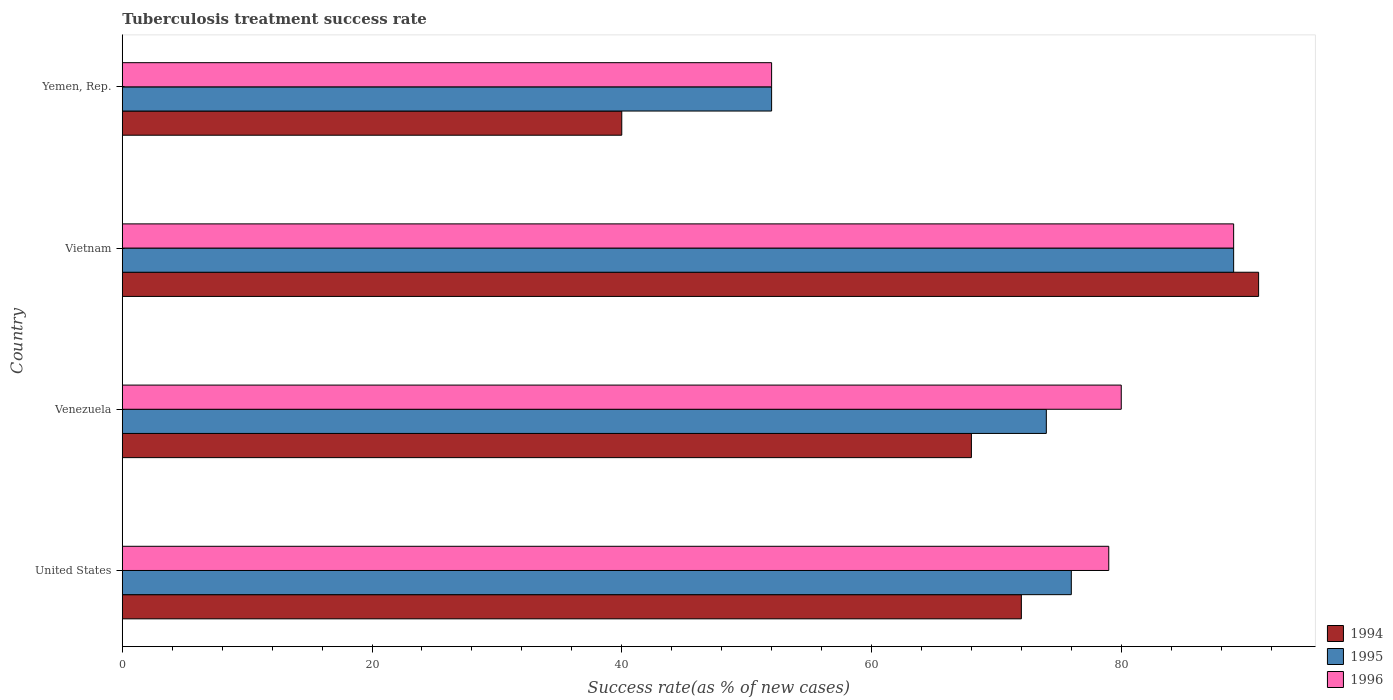How many different coloured bars are there?
Offer a terse response. 3. Are the number of bars on each tick of the Y-axis equal?
Your answer should be very brief. Yes. What is the tuberculosis treatment success rate in 1995 in Yemen, Rep.?
Give a very brief answer. 52. Across all countries, what is the maximum tuberculosis treatment success rate in 1995?
Offer a terse response. 89. Across all countries, what is the minimum tuberculosis treatment success rate in 1995?
Provide a short and direct response. 52. In which country was the tuberculosis treatment success rate in 1994 maximum?
Provide a succinct answer. Vietnam. In which country was the tuberculosis treatment success rate in 1995 minimum?
Your answer should be compact. Yemen, Rep. What is the total tuberculosis treatment success rate in 1995 in the graph?
Ensure brevity in your answer.  291. What is the difference between the tuberculosis treatment success rate in 1996 in United States and the tuberculosis treatment success rate in 1995 in Venezuela?
Provide a succinct answer. 5. What is the average tuberculosis treatment success rate in 1995 per country?
Provide a succinct answer. 72.75. In how many countries, is the tuberculosis treatment success rate in 1996 greater than 28 %?
Your answer should be compact. 4. What is the ratio of the tuberculosis treatment success rate in 1996 in Venezuela to that in Yemen, Rep.?
Keep it short and to the point. 1.54. Is the tuberculosis treatment success rate in 1994 in Venezuela less than that in Yemen, Rep.?
Give a very brief answer. No. What is the difference between the highest and the second highest tuberculosis treatment success rate in 1996?
Offer a terse response. 9. In how many countries, is the tuberculosis treatment success rate in 1996 greater than the average tuberculosis treatment success rate in 1996 taken over all countries?
Your response must be concise. 3. Is the sum of the tuberculosis treatment success rate in 1995 in Vietnam and Yemen, Rep. greater than the maximum tuberculosis treatment success rate in 1996 across all countries?
Your response must be concise. Yes. Is it the case that in every country, the sum of the tuberculosis treatment success rate in 1995 and tuberculosis treatment success rate in 1996 is greater than the tuberculosis treatment success rate in 1994?
Give a very brief answer. Yes. How many bars are there?
Your answer should be very brief. 12. How many countries are there in the graph?
Ensure brevity in your answer.  4. Where does the legend appear in the graph?
Offer a very short reply. Bottom right. What is the title of the graph?
Your answer should be very brief. Tuberculosis treatment success rate. Does "1984" appear as one of the legend labels in the graph?
Provide a succinct answer. No. What is the label or title of the X-axis?
Make the answer very short. Success rate(as % of new cases). What is the label or title of the Y-axis?
Offer a very short reply. Country. What is the Success rate(as % of new cases) in 1996 in United States?
Provide a succinct answer. 79. What is the Success rate(as % of new cases) of 1996 in Venezuela?
Keep it short and to the point. 80. What is the Success rate(as % of new cases) in 1994 in Vietnam?
Offer a terse response. 91. What is the Success rate(as % of new cases) of 1995 in Vietnam?
Offer a very short reply. 89. What is the Success rate(as % of new cases) of 1996 in Vietnam?
Your answer should be very brief. 89. What is the Success rate(as % of new cases) in 1995 in Yemen, Rep.?
Ensure brevity in your answer.  52. What is the Success rate(as % of new cases) of 1996 in Yemen, Rep.?
Your answer should be very brief. 52. Across all countries, what is the maximum Success rate(as % of new cases) of 1994?
Provide a succinct answer. 91. Across all countries, what is the maximum Success rate(as % of new cases) in 1995?
Offer a terse response. 89. Across all countries, what is the maximum Success rate(as % of new cases) of 1996?
Offer a very short reply. 89. Across all countries, what is the minimum Success rate(as % of new cases) of 1994?
Give a very brief answer. 40. Across all countries, what is the minimum Success rate(as % of new cases) in 1995?
Provide a short and direct response. 52. What is the total Success rate(as % of new cases) in 1994 in the graph?
Ensure brevity in your answer.  271. What is the total Success rate(as % of new cases) of 1995 in the graph?
Ensure brevity in your answer.  291. What is the total Success rate(as % of new cases) in 1996 in the graph?
Ensure brevity in your answer.  300. What is the difference between the Success rate(as % of new cases) of 1994 in United States and that in Venezuela?
Offer a terse response. 4. What is the difference between the Success rate(as % of new cases) in 1995 in United States and that in Venezuela?
Your response must be concise. 2. What is the difference between the Success rate(as % of new cases) of 1996 in United States and that in Venezuela?
Give a very brief answer. -1. What is the difference between the Success rate(as % of new cases) of 1994 in United States and that in Yemen, Rep.?
Your answer should be compact. 32. What is the difference between the Success rate(as % of new cases) of 1995 in United States and that in Yemen, Rep.?
Make the answer very short. 24. What is the difference between the Success rate(as % of new cases) in 1996 in United States and that in Yemen, Rep.?
Give a very brief answer. 27. What is the difference between the Success rate(as % of new cases) in 1994 in Venezuela and that in Vietnam?
Provide a succinct answer. -23. What is the difference between the Success rate(as % of new cases) in 1994 in Venezuela and that in Yemen, Rep.?
Give a very brief answer. 28. What is the difference between the Success rate(as % of new cases) of 1994 in Vietnam and that in Yemen, Rep.?
Your answer should be compact. 51. What is the difference between the Success rate(as % of new cases) in 1996 in Vietnam and that in Yemen, Rep.?
Give a very brief answer. 37. What is the difference between the Success rate(as % of new cases) of 1994 in United States and the Success rate(as % of new cases) of 1996 in Vietnam?
Your response must be concise. -17. What is the difference between the Success rate(as % of new cases) in 1995 in United States and the Success rate(as % of new cases) in 1996 in Vietnam?
Make the answer very short. -13. What is the difference between the Success rate(as % of new cases) in 1994 in United States and the Success rate(as % of new cases) in 1995 in Yemen, Rep.?
Give a very brief answer. 20. What is the difference between the Success rate(as % of new cases) in 1994 in Venezuela and the Success rate(as % of new cases) in 1995 in Vietnam?
Keep it short and to the point. -21. What is the difference between the Success rate(as % of new cases) of 1994 in Venezuela and the Success rate(as % of new cases) of 1995 in Yemen, Rep.?
Give a very brief answer. 16. What is the difference between the Success rate(as % of new cases) of 1995 in Venezuela and the Success rate(as % of new cases) of 1996 in Yemen, Rep.?
Offer a very short reply. 22. What is the difference between the Success rate(as % of new cases) of 1994 in Vietnam and the Success rate(as % of new cases) of 1996 in Yemen, Rep.?
Keep it short and to the point. 39. What is the difference between the Success rate(as % of new cases) in 1995 in Vietnam and the Success rate(as % of new cases) in 1996 in Yemen, Rep.?
Your answer should be compact. 37. What is the average Success rate(as % of new cases) of 1994 per country?
Offer a very short reply. 67.75. What is the average Success rate(as % of new cases) in 1995 per country?
Ensure brevity in your answer.  72.75. What is the average Success rate(as % of new cases) of 1996 per country?
Keep it short and to the point. 75. What is the difference between the Success rate(as % of new cases) of 1994 and Success rate(as % of new cases) of 1995 in United States?
Keep it short and to the point. -4. What is the difference between the Success rate(as % of new cases) of 1994 and Success rate(as % of new cases) of 1995 in Vietnam?
Ensure brevity in your answer.  2. What is the difference between the Success rate(as % of new cases) in 1994 and Success rate(as % of new cases) in 1996 in Vietnam?
Give a very brief answer. 2. What is the difference between the Success rate(as % of new cases) in 1994 and Success rate(as % of new cases) in 1996 in Yemen, Rep.?
Provide a short and direct response. -12. What is the ratio of the Success rate(as % of new cases) in 1994 in United States to that in Venezuela?
Ensure brevity in your answer.  1.06. What is the ratio of the Success rate(as % of new cases) of 1995 in United States to that in Venezuela?
Provide a short and direct response. 1.03. What is the ratio of the Success rate(as % of new cases) of 1996 in United States to that in Venezuela?
Give a very brief answer. 0.99. What is the ratio of the Success rate(as % of new cases) in 1994 in United States to that in Vietnam?
Provide a succinct answer. 0.79. What is the ratio of the Success rate(as % of new cases) in 1995 in United States to that in Vietnam?
Your answer should be compact. 0.85. What is the ratio of the Success rate(as % of new cases) in 1996 in United States to that in Vietnam?
Ensure brevity in your answer.  0.89. What is the ratio of the Success rate(as % of new cases) of 1995 in United States to that in Yemen, Rep.?
Your response must be concise. 1.46. What is the ratio of the Success rate(as % of new cases) in 1996 in United States to that in Yemen, Rep.?
Provide a short and direct response. 1.52. What is the ratio of the Success rate(as % of new cases) of 1994 in Venezuela to that in Vietnam?
Give a very brief answer. 0.75. What is the ratio of the Success rate(as % of new cases) of 1995 in Venezuela to that in Vietnam?
Give a very brief answer. 0.83. What is the ratio of the Success rate(as % of new cases) of 1996 in Venezuela to that in Vietnam?
Provide a short and direct response. 0.9. What is the ratio of the Success rate(as % of new cases) in 1994 in Venezuela to that in Yemen, Rep.?
Provide a short and direct response. 1.7. What is the ratio of the Success rate(as % of new cases) of 1995 in Venezuela to that in Yemen, Rep.?
Your answer should be very brief. 1.42. What is the ratio of the Success rate(as % of new cases) in 1996 in Venezuela to that in Yemen, Rep.?
Your response must be concise. 1.54. What is the ratio of the Success rate(as % of new cases) of 1994 in Vietnam to that in Yemen, Rep.?
Offer a very short reply. 2.27. What is the ratio of the Success rate(as % of new cases) in 1995 in Vietnam to that in Yemen, Rep.?
Offer a very short reply. 1.71. What is the ratio of the Success rate(as % of new cases) in 1996 in Vietnam to that in Yemen, Rep.?
Keep it short and to the point. 1.71. What is the difference between the highest and the second highest Success rate(as % of new cases) in 1995?
Ensure brevity in your answer.  13. What is the difference between the highest and the second highest Success rate(as % of new cases) in 1996?
Give a very brief answer. 9. What is the difference between the highest and the lowest Success rate(as % of new cases) of 1995?
Your answer should be very brief. 37. 